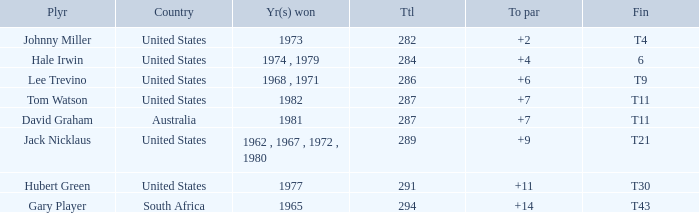WHAT IS THE TOTAL THAT HAS A WIN IN 1982? 287.0. 